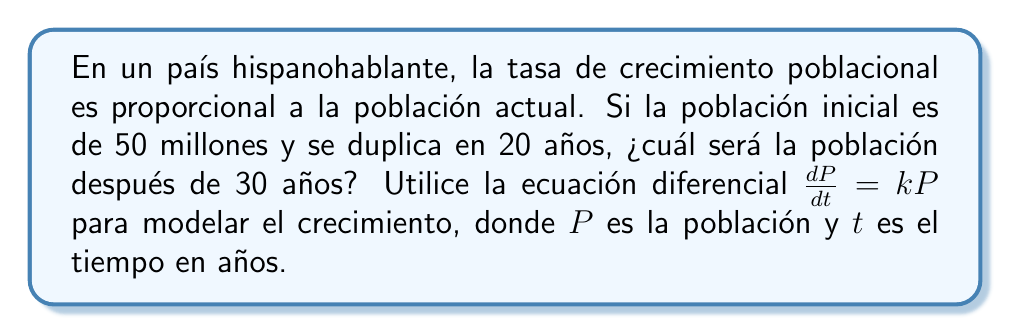Can you solve this math problem? 1. Comencemos con la ecuación diferencial para el crecimiento exponencial:
   $$\frac{dP}{dt} = kP$$

2. La solución general de esta ecuación es:
   $$P(t) = P_0e^{kt}$$
   donde $P_0$ es la población inicial.

3. Sabemos que $P_0 = 50$ millones y que la población se duplica en 20 años. Usemos esto para encontrar $k$:
   $$2P_0 = P_0e^{20k}$$
   $$2 = e^{20k}$$
   $$\ln(2) = 20k$$
   $$k = \frac{\ln(2)}{20} \approx 0.0347$$

4. Ahora que tenemos $k$, podemos calcular la población después de 30 años:
   $$P(30) = 50e^{0.0347 \cdot 30}$$
   $$P(30) = 50e^{1.041} \approx 141.64$$

5. Por lo tanto, la población después de 30 años será aproximadamente 141.64 millones.
Answer: 141.64 millones 